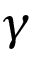Convert formula to latex. <formula><loc_0><loc_0><loc_500><loc_500>\gamma</formula> 